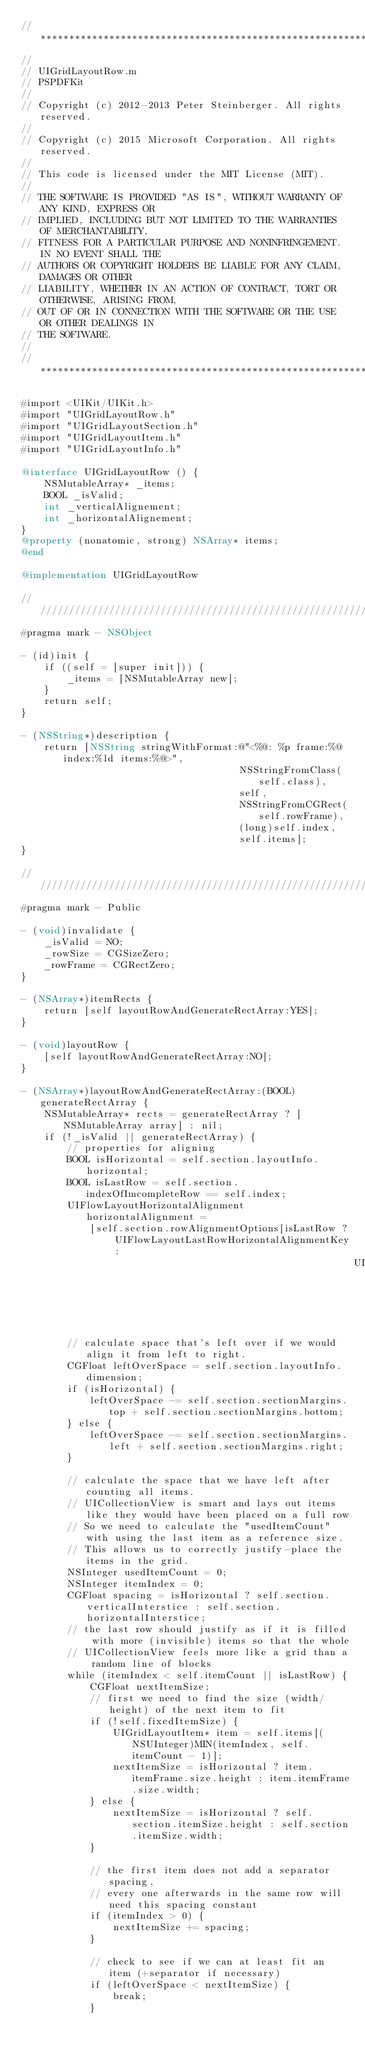<code> <loc_0><loc_0><loc_500><loc_500><_ObjectiveC_>//******************************************************************************
//
// UIGridLayoutRow.m
// PSPDFKit
//
// Copyright (c) 2012-2013 Peter Steinberger. All rights reserved.
//
// Copyright (c) 2015 Microsoft Corporation. All rights reserved.
//
// This code is licensed under the MIT License (MIT).
//
// THE SOFTWARE IS PROVIDED "AS IS", WITHOUT WARRANTY OF ANY KIND, EXPRESS OR
// IMPLIED, INCLUDING BUT NOT LIMITED TO THE WARRANTIES OF MERCHANTABILITY,
// FITNESS FOR A PARTICULAR PURPOSE AND NONINFRINGEMENT. IN NO EVENT SHALL THE
// AUTHORS OR COPYRIGHT HOLDERS BE LIABLE FOR ANY CLAIM, DAMAGES OR OTHER
// LIABILITY, WHETHER IN AN ACTION OF CONTRACT, TORT OR OTHERWISE, ARISING FROM,
// OUT OF OR IN CONNECTION WITH THE SOFTWARE OR THE USE OR OTHER DEALINGS IN
// THE SOFTWARE.
//
//******************************************************************************

#import <UIKit/UIKit.h>
#import "UIGridLayoutRow.h"
#import "UIGridLayoutSection.h"
#import "UIGridLayoutItem.h"
#import "UIGridLayoutInfo.h"

@interface UIGridLayoutRow () {
    NSMutableArray* _items;
    BOOL _isValid;
    int _verticalAlignement;
    int _horizontalAlignement;
}
@property (nonatomic, strong) NSArray* items;
@end

@implementation UIGridLayoutRow

///////////////////////////////////////////////////////////////////////////////////////////
#pragma mark - NSObject

- (id)init {
    if ((self = [super init])) {
        _items = [NSMutableArray new];
    }
    return self;
}

- (NSString*)description {
    return [NSString stringWithFormat:@"<%@: %p frame:%@ index:%ld items:%@>",
                                      NSStringFromClass(self.class),
                                      self,
                                      NSStringFromCGRect(self.rowFrame),
                                      (long)self.index,
                                      self.items];
}

///////////////////////////////////////////////////////////////////////////////////////////
#pragma mark - Public

- (void)invalidate {
    _isValid = NO;
    _rowSize = CGSizeZero;
    _rowFrame = CGRectZero;
}

- (NSArray*)itemRects {
    return [self layoutRowAndGenerateRectArray:YES];
}

- (void)layoutRow {
    [self layoutRowAndGenerateRectArray:NO];
}

- (NSArray*)layoutRowAndGenerateRectArray:(BOOL)generateRectArray {
    NSMutableArray* rects = generateRectArray ? [NSMutableArray array] : nil;
    if (!_isValid || generateRectArray) {
        // properties for aligning
        BOOL isHorizontal = self.section.layoutInfo.horizontal;
        BOOL isLastRow = self.section.indexOfImcompleteRow == self.index;
        UIFlowLayoutHorizontalAlignment horizontalAlignment =
            [self.section.rowAlignmentOptions[isLastRow ? UIFlowLayoutLastRowHorizontalAlignmentKey :
                                                          UIFlowLayoutCommonRowHorizontalAlignmentKey] integerValue];

        // calculate space that's left over if we would align it from left to right.
        CGFloat leftOverSpace = self.section.layoutInfo.dimension;
        if (isHorizontal) {
            leftOverSpace -= self.section.sectionMargins.top + self.section.sectionMargins.bottom;
        } else {
            leftOverSpace -= self.section.sectionMargins.left + self.section.sectionMargins.right;
        }

        // calculate the space that we have left after counting all items.
        // UICollectionView is smart and lays out items like they would have been placed on a full row
        // So we need to calculate the "usedItemCount" with using the last item as a reference size.
        // This allows us to correctly justify-place the items in the grid.
        NSInteger usedItemCount = 0;
        NSInteger itemIndex = 0;
        CGFloat spacing = isHorizontal ? self.section.verticalInterstice : self.section.horizontalInterstice;
        // the last row should justify as if it is filled with more (invisible) items so that the whole
        // UICollectionView feels more like a grid than a random line of blocks
        while (itemIndex < self.itemCount || isLastRow) {
            CGFloat nextItemSize;
            // first we need to find the size (width/height) of the next item to fit
            if (!self.fixedItemSize) {
                UIGridLayoutItem* item = self.items[(NSUInteger)MIN(itemIndex, self.itemCount - 1)];
                nextItemSize = isHorizontal ? item.itemFrame.size.height : item.itemFrame.size.width;
            } else {
                nextItemSize = isHorizontal ? self.section.itemSize.height : self.section.itemSize.width;
            }

            // the first item does not add a separator spacing,
            // every one afterwards in the same row will need this spacing constant
            if (itemIndex > 0) {
                nextItemSize += spacing;
            }

            // check to see if we can at least fit an item (+separator if necessary)
            if (leftOverSpace < nextItemSize) {
                break;
            }
</code> 